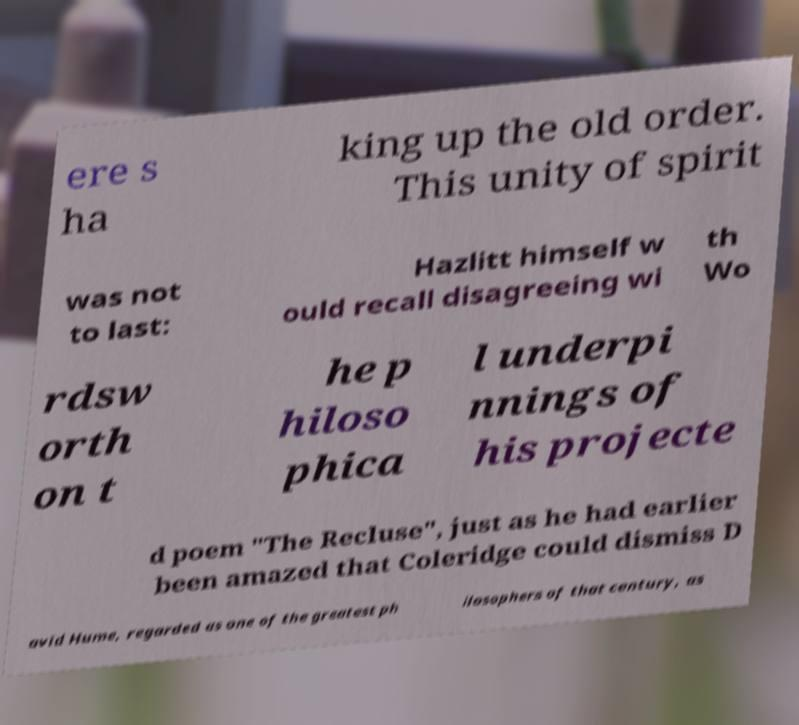Could you assist in decoding the text presented in this image and type it out clearly? ere s ha king up the old order. This unity of spirit was not to last: Hazlitt himself w ould recall disagreeing wi th Wo rdsw orth on t he p hiloso phica l underpi nnings of his projecte d poem "The Recluse", just as he had earlier been amazed that Coleridge could dismiss D avid Hume, regarded as one of the greatest ph ilosophers of that century, as 